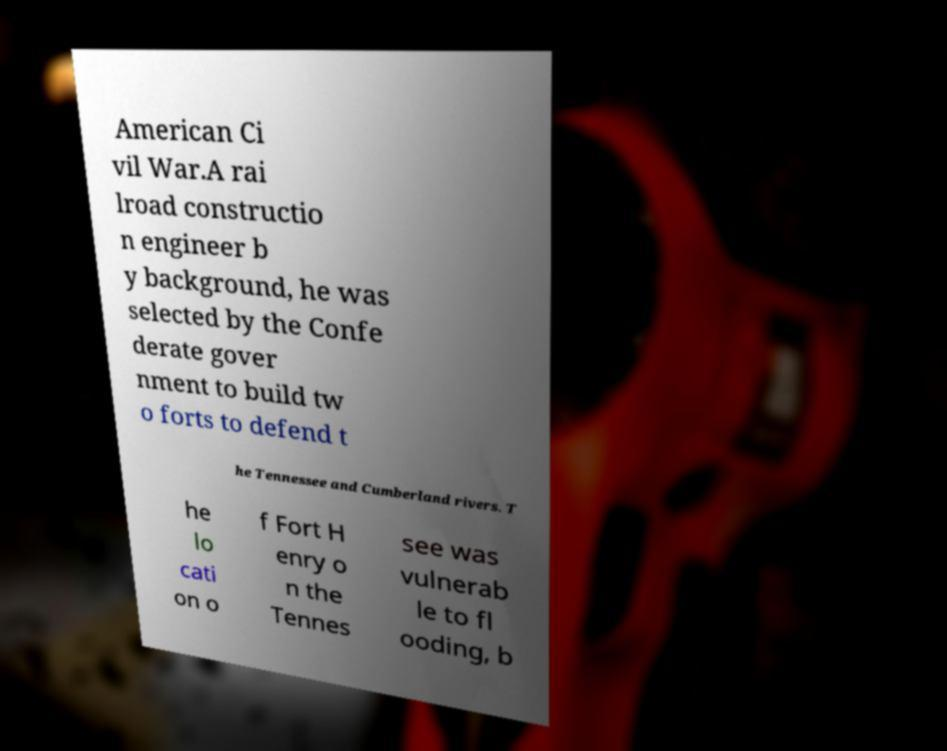Can you accurately transcribe the text from the provided image for me? American Ci vil War.A rai lroad constructio n engineer b y background, he was selected by the Confe derate gover nment to build tw o forts to defend t he Tennessee and Cumberland rivers. T he lo cati on o f Fort H enry o n the Tennes see was vulnerab le to fl ooding, b 